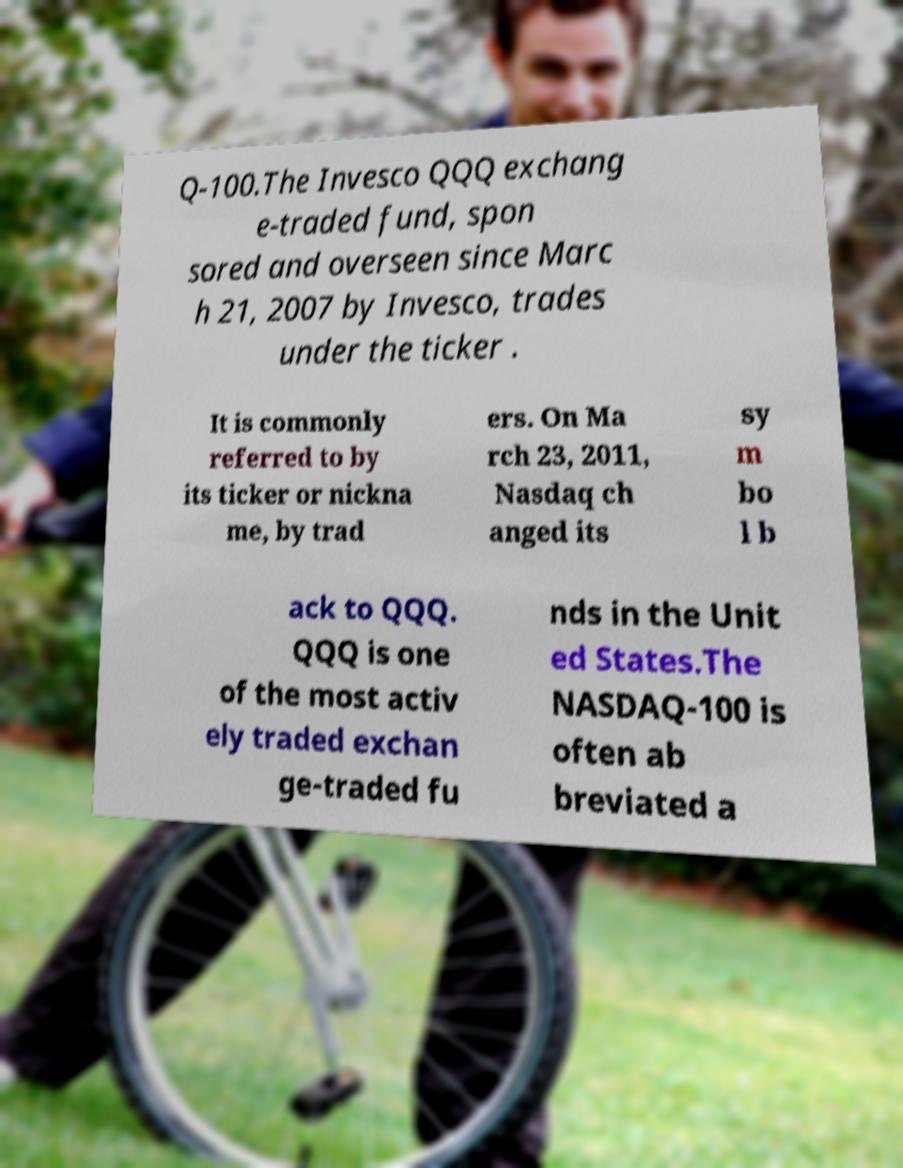Could you extract and type out the text from this image? Q-100.The Invesco QQQ exchang e-traded fund, spon sored and overseen since Marc h 21, 2007 by Invesco, trades under the ticker . It is commonly referred to by its ticker or nickna me, by trad ers. On Ma rch 23, 2011, Nasdaq ch anged its sy m bo l b ack to QQQ. QQQ is one of the most activ ely traded exchan ge-traded fu nds in the Unit ed States.The NASDAQ-100 is often ab breviated a 